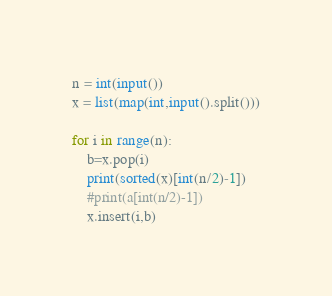Convert code to text. <code><loc_0><loc_0><loc_500><loc_500><_Python_>n = int(input())
x = list(map(int,input().split()))

for i in range(n):
    b=x.pop(i)
    print(sorted(x)[int(n/2)-1])
    #print(a[int(n/2)-1])
    x.insert(i,b)</code> 